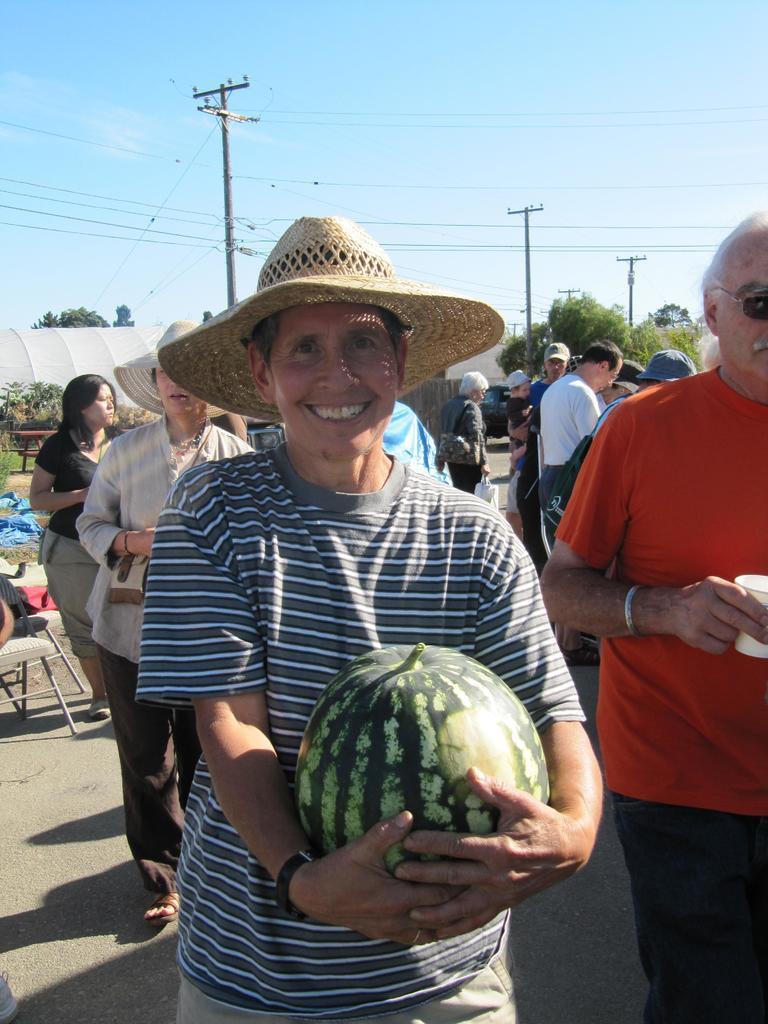In one or two sentences, can you explain what this image depicts? In the center of the image we can see one person standing and smiling. And he is holding one watermelon and he is wearing a hat. And we can see a few people are standing and few people are wearing caps. And few people are holding some objects. In the background we can see the sky, clouds, trees, grass, chairs, tents etc. 